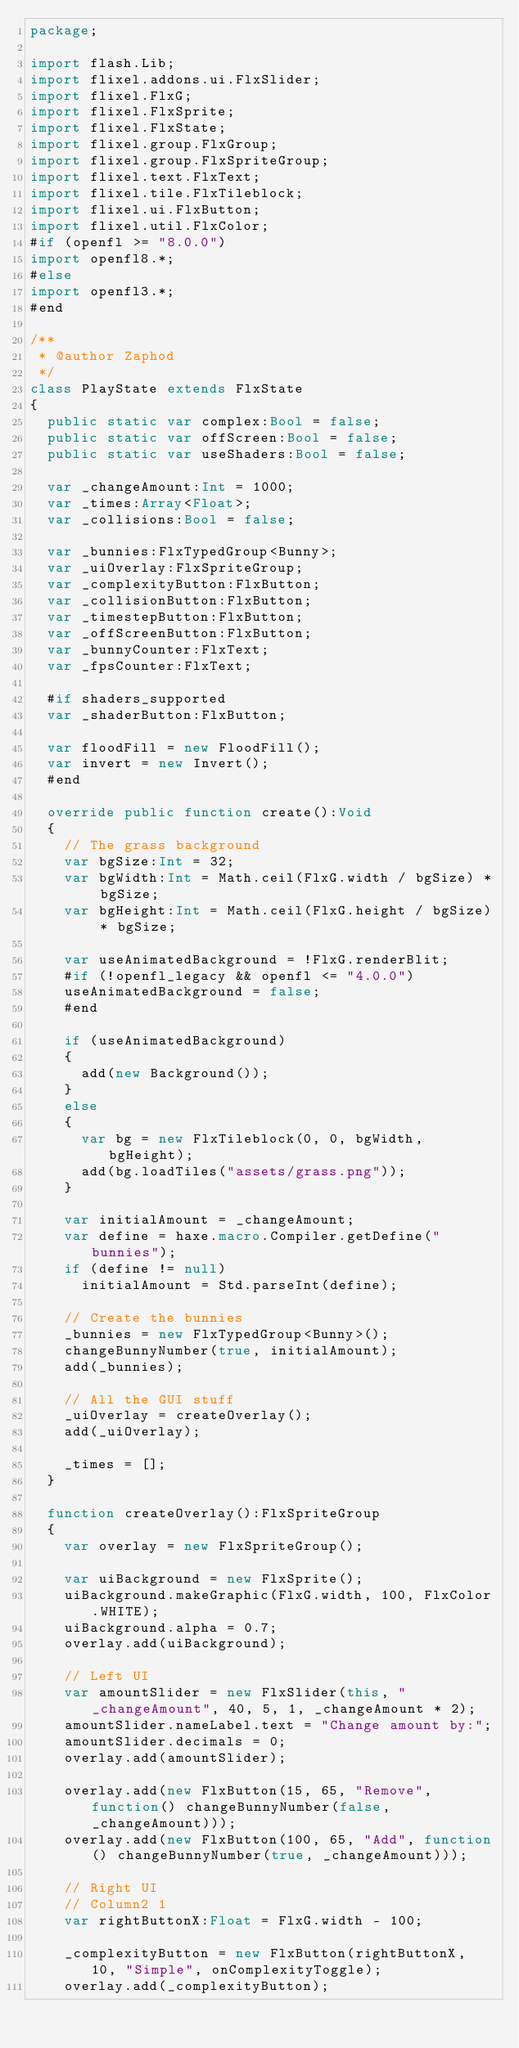Convert code to text. <code><loc_0><loc_0><loc_500><loc_500><_Haxe_>package;

import flash.Lib;
import flixel.addons.ui.FlxSlider;
import flixel.FlxG;
import flixel.FlxSprite;
import flixel.FlxState;
import flixel.group.FlxGroup;
import flixel.group.FlxSpriteGroup;
import flixel.text.FlxText;
import flixel.tile.FlxTileblock;
import flixel.ui.FlxButton;
import flixel.util.FlxColor;
#if (openfl >= "8.0.0")
import openfl8.*;
#else
import openfl3.*;
#end

/**
 * @author Zaphod
 */
class PlayState extends FlxState
{
	public static var complex:Bool = false;
	public static var offScreen:Bool = false;
	public static var useShaders:Bool = false;

	var _changeAmount:Int = 1000;
	var _times:Array<Float>;
	var _collisions:Bool = false;

	var _bunnies:FlxTypedGroup<Bunny>;
	var _uiOverlay:FlxSpriteGroup;
	var _complexityButton:FlxButton;
	var _collisionButton:FlxButton;
	var _timestepButton:FlxButton;
	var _offScreenButton:FlxButton;
	var _bunnyCounter:FlxText;
	var _fpsCounter:FlxText;

	#if shaders_supported
	var _shaderButton:FlxButton;

	var floodFill = new FloodFill();
	var invert = new Invert();
	#end

	override public function create():Void
	{
		// The grass background
		var bgSize:Int = 32;
		var bgWidth:Int = Math.ceil(FlxG.width / bgSize) * bgSize;
		var bgHeight:Int = Math.ceil(FlxG.height / bgSize) * bgSize;

		var useAnimatedBackground = !FlxG.renderBlit;
		#if (!openfl_legacy && openfl <= "4.0.0")
		useAnimatedBackground = false;
		#end

		if (useAnimatedBackground)
		{
			add(new Background());
		}
		else
		{
			var bg = new FlxTileblock(0, 0, bgWidth, bgHeight);
			add(bg.loadTiles("assets/grass.png"));
		}

		var initialAmount = _changeAmount;
		var define = haxe.macro.Compiler.getDefine("bunnies");
		if (define != null)
			initialAmount = Std.parseInt(define);

		// Create the bunnies
		_bunnies = new FlxTypedGroup<Bunny>();
		changeBunnyNumber(true, initialAmount);
		add(_bunnies);

		// All the GUI stuff
		_uiOverlay = createOverlay();
		add(_uiOverlay);

		_times = [];
	}

	function createOverlay():FlxSpriteGroup
	{
		var overlay = new FlxSpriteGroup();

		var uiBackground = new FlxSprite();
		uiBackground.makeGraphic(FlxG.width, 100, FlxColor.WHITE);
		uiBackground.alpha = 0.7;
		overlay.add(uiBackground);

		// Left UI
		var amountSlider = new FlxSlider(this, "_changeAmount", 40, 5, 1, _changeAmount * 2);
		amountSlider.nameLabel.text = "Change amount by:";
		amountSlider.decimals = 0;
		overlay.add(amountSlider);

		overlay.add(new FlxButton(15, 65, "Remove", function() changeBunnyNumber(false, _changeAmount)));
		overlay.add(new FlxButton(100, 65, "Add", function() changeBunnyNumber(true, _changeAmount)));

		// Right UI
		// Column2 1
		var rightButtonX:Float = FlxG.width - 100;

		_complexityButton = new FlxButton(rightButtonX, 10, "Simple", onComplexityToggle);
		overlay.add(_complexityButton);
</code> 